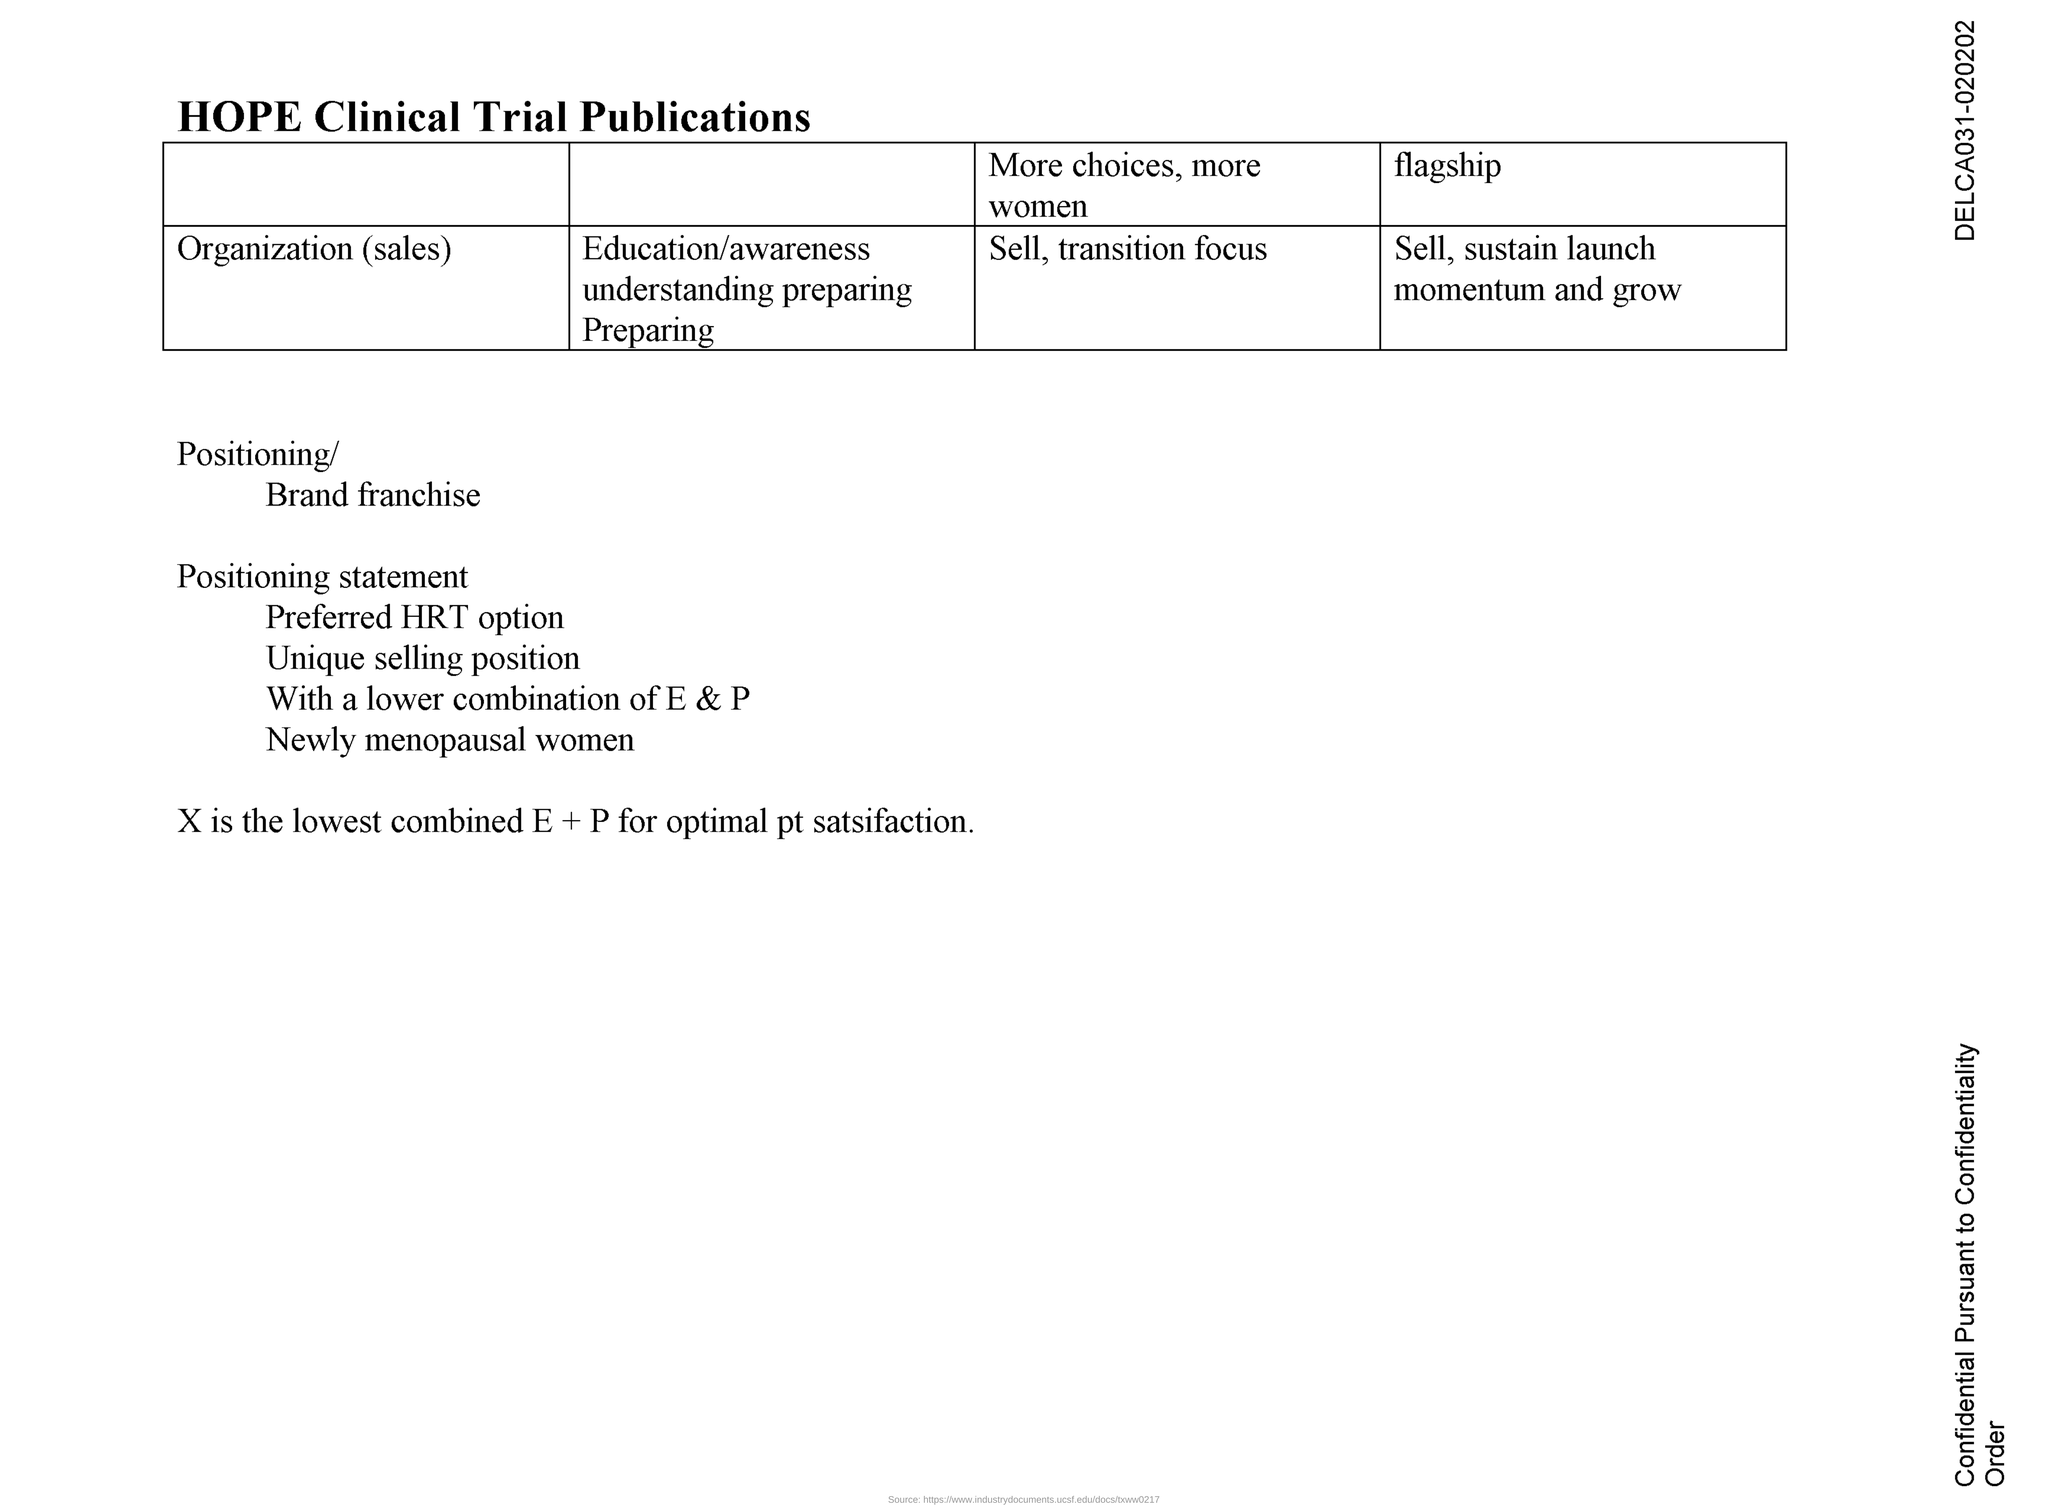Point out several critical features in this image. The fourth column of the table is titled "flagship. The title of the document is "What is the title of the document? HOPE Clinical Trial Publications.." 